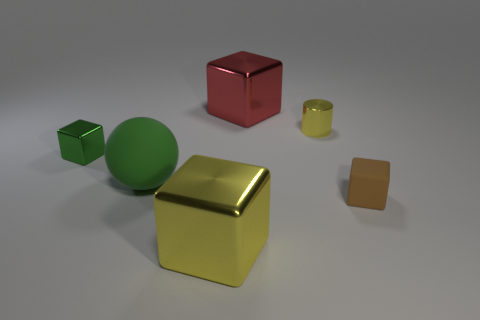There is a tiny cube that is the same color as the matte ball; what is its material?
Offer a terse response. Metal. What is the shape of the shiny object that is the same color as the tiny shiny cylinder?
Offer a terse response. Cube. Are there any blue rubber spheres of the same size as the cylinder?
Give a very brief answer. No. There is a tiny rubber thing that is the same shape as the small green shiny object; what is its color?
Make the answer very short. Brown. There is a shiny thing that is to the left of the big yellow metallic cube; does it have the same size as the metallic cube that is behind the green cube?
Your response must be concise. No. Is there a big gray matte object that has the same shape as the big yellow thing?
Your response must be concise. No. Are there the same number of red cubes on the left side of the red shiny object and green metal objects?
Your answer should be compact. No. Does the yellow block have the same size as the matte thing left of the tiny matte object?
Give a very brief answer. Yes. How many yellow blocks are made of the same material as the yellow cylinder?
Provide a succinct answer. 1. Do the green shiny thing and the red cube have the same size?
Keep it short and to the point. No. 